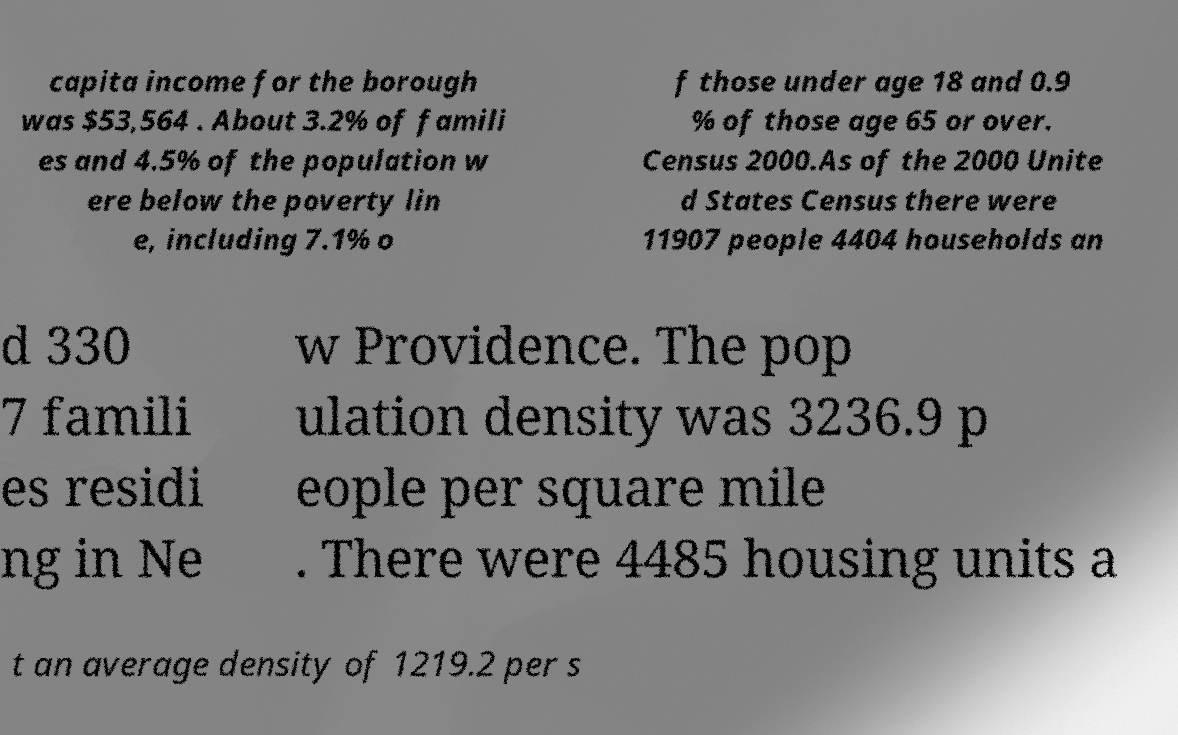Could you assist in decoding the text presented in this image and type it out clearly? capita income for the borough was $53,564 . About 3.2% of famili es and 4.5% of the population w ere below the poverty lin e, including 7.1% o f those under age 18 and 0.9 % of those age 65 or over. Census 2000.As of the 2000 Unite d States Census there were 11907 people 4404 households an d 330 7 famili es residi ng in Ne w Providence. The pop ulation density was 3236.9 p eople per square mile . There were 4485 housing units a t an average density of 1219.2 per s 